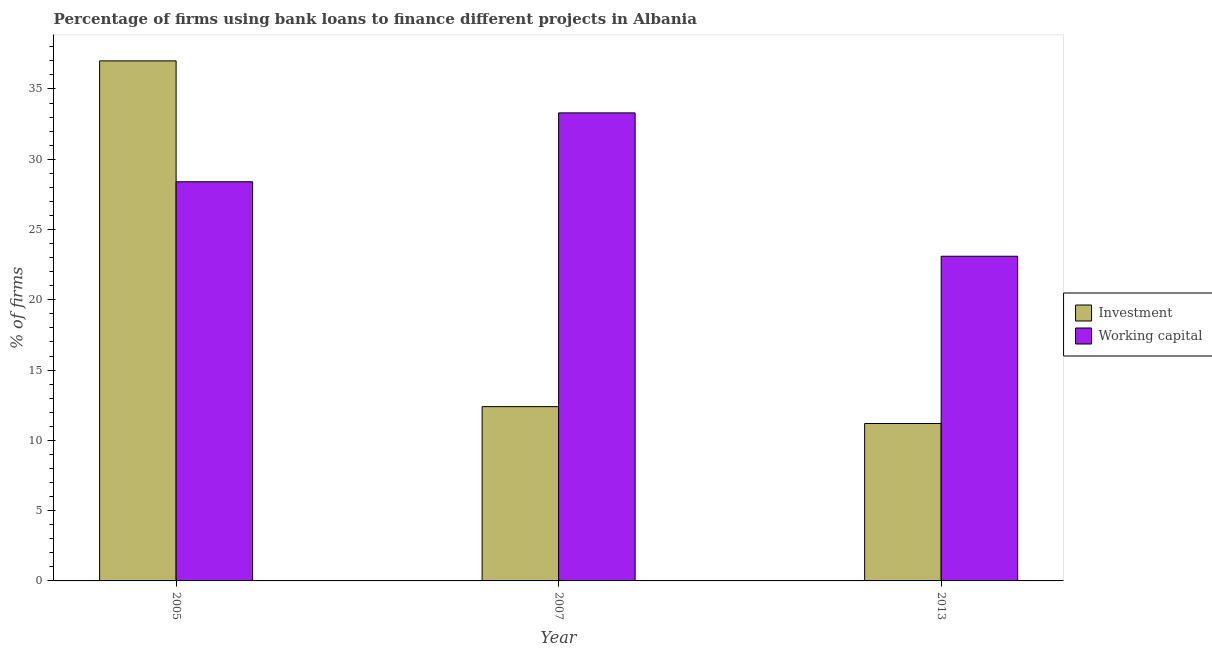How many different coloured bars are there?
Keep it short and to the point. 2. How many groups of bars are there?
Offer a very short reply. 3. Are the number of bars per tick equal to the number of legend labels?
Provide a short and direct response. Yes. In how many cases, is the number of bars for a given year not equal to the number of legend labels?
Your answer should be compact. 0. Across all years, what is the maximum percentage of firms using banks to finance working capital?
Make the answer very short. 33.3. What is the total percentage of firms using banks to finance investment in the graph?
Your answer should be very brief. 60.6. What is the difference between the percentage of firms using banks to finance investment in 2007 and that in 2013?
Ensure brevity in your answer.  1.2. What is the difference between the percentage of firms using banks to finance working capital in 2005 and the percentage of firms using banks to finance investment in 2013?
Your response must be concise. 5.3. What is the average percentage of firms using banks to finance working capital per year?
Your answer should be very brief. 28.27. In the year 2007, what is the difference between the percentage of firms using banks to finance investment and percentage of firms using banks to finance working capital?
Offer a terse response. 0. What is the ratio of the percentage of firms using banks to finance working capital in 2005 to that in 2013?
Offer a very short reply. 1.23. Is the percentage of firms using banks to finance working capital in 2007 less than that in 2013?
Ensure brevity in your answer.  No. What is the difference between the highest and the second highest percentage of firms using banks to finance working capital?
Your answer should be very brief. 4.9. What is the difference between the highest and the lowest percentage of firms using banks to finance investment?
Offer a very short reply. 25.8. In how many years, is the percentage of firms using banks to finance investment greater than the average percentage of firms using banks to finance investment taken over all years?
Provide a succinct answer. 1. Is the sum of the percentage of firms using banks to finance investment in 2007 and 2013 greater than the maximum percentage of firms using banks to finance working capital across all years?
Your answer should be very brief. No. What does the 1st bar from the left in 2005 represents?
Provide a succinct answer. Investment. What does the 2nd bar from the right in 2013 represents?
Make the answer very short. Investment. How many bars are there?
Ensure brevity in your answer.  6. How many years are there in the graph?
Your answer should be very brief. 3. What is the difference between two consecutive major ticks on the Y-axis?
Your response must be concise. 5. How are the legend labels stacked?
Your answer should be compact. Vertical. What is the title of the graph?
Keep it short and to the point. Percentage of firms using bank loans to finance different projects in Albania. What is the label or title of the Y-axis?
Provide a short and direct response. % of firms. What is the % of firms in Investment in 2005?
Provide a short and direct response. 37. What is the % of firms in Working capital in 2005?
Give a very brief answer. 28.4. What is the % of firms in Investment in 2007?
Offer a very short reply. 12.4. What is the % of firms in Working capital in 2007?
Provide a succinct answer. 33.3. What is the % of firms of Investment in 2013?
Keep it short and to the point. 11.2. What is the % of firms of Working capital in 2013?
Your answer should be very brief. 23.1. Across all years, what is the maximum % of firms of Investment?
Offer a terse response. 37. Across all years, what is the maximum % of firms of Working capital?
Provide a short and direct response. 33.3. Across all years, what is the minimum % of firms in Working capital?
Make the answer very short. 23.1. What is the total % of firms in Investment in the graph?
Your answer should be very brief. 60.6. What is the total % of firms of Working capital in the graph?
Provide a succinct answer. 84.8. What is the difference between the % of firms of Investment in 2005 and that in 2007?
Provide a short and direct response. 24.6. What is the difference between the % of firms in Investment in 2005 and that in 2013?
Give a very brief answer. 25.8. What is the difference between the % of firms in Working capital in 2007 and that in 2013?
Keep it short and to the point. 10.2. What is the difference between the % of firms in Investment in 2005 and the % of firms in Working capital in 2007?
Make the answer very short. 3.7. What is the difference between the % of firms in Investment in 2005 and the % of firms in Working capital in 2013?
Give a very brief answer. 13.9. What is the average % of firms in Investment per year?
Your answer should be very brief. 20.2. What is the average % of firms in Working capital per year?
Provide a succinct answer. 28.27. In the year 2005, what is the difference between the % of firms of Investment and % of firms of Working capital?
Ensure brevity in your answer.  8.6. In the year 2007, what is the difference between the % of firms in Investment and % of firms in Working capital?
Provide a short and direct response. -20.9. What is the ratio of the % of firms in Investment in 2005 to that in 2007?
Your response must be concise. 2.98. What is the ratio of the % of firms in Working capital in 2005 to that in 2007?
Your response must be concise. 0.85. What is the ratio of the % of firms in Investment in 2005 to that in 2013?
Ensure brevity in your answer.  3.3. What is the ratio of the % of firms in Working capital in 2005 to that in 2013?
Your answer should be compact. 1.23. What is the ratio of the % of firms of Investment in 2007 to that in 2013?
Offer a terse response. 1.11. What is the ratio of the % of firms in Working capital in 2007 to that in 2013?
Ensure brevity in your answer.  1.44. What is the difference between the highest and the second highest % of firms of Investment?
Provide a succinct answer. 24.6. What is the difference between the highest and the lowest % of firms of Investment?
Your answer should be very brief. 25.8. 